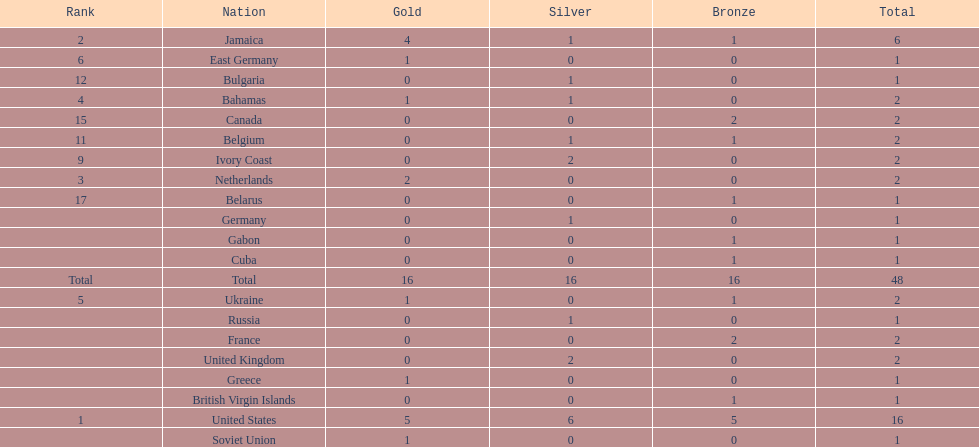How many nations received more medals than canada? 2. 